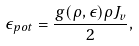<formula> <loc_0><loc_0><loc_500><loc_500>\epsilon _ { p o t } = \frac { g ( \rho , \epsilon ) \rho J _ { v } } { 2 } ,</formula> 